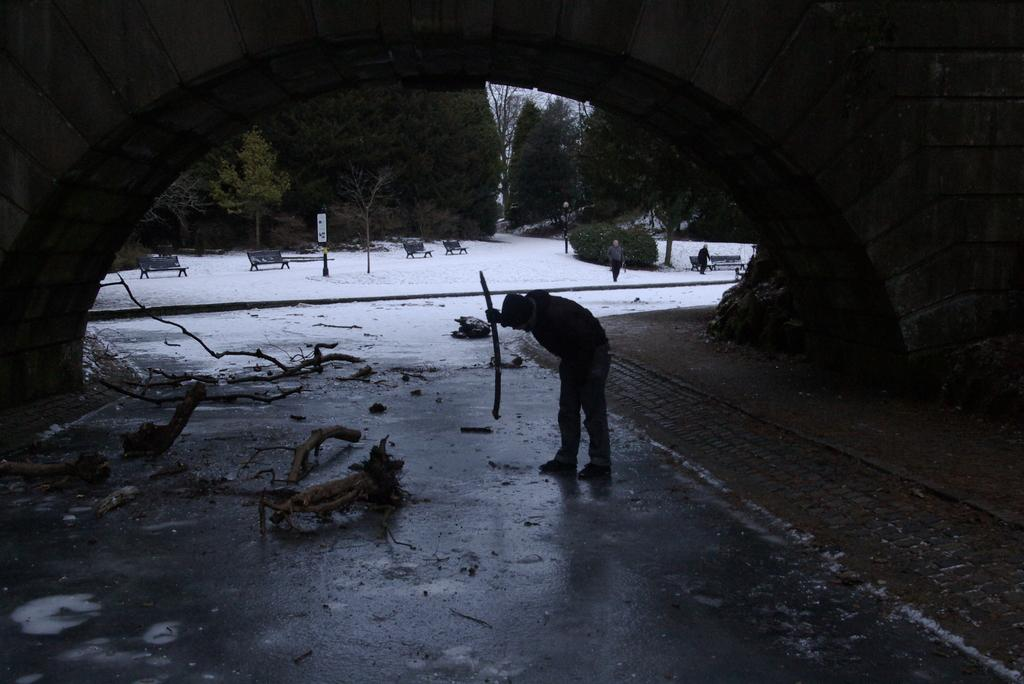What is the person in the image holding? The facts do not specify what the person is holding. What can be seen in the background of the image? In the background, there are benches, signboards, trees, and snow visible. How many different objects can be seen in the background? There are four different objects visible in the background: benches, signboards, trees, and snow. How many deer are visible in the image? There are no deer present in the image. What type of insurance policy is being advertised on the signboards in the image? The facts do not mention any signboards advertising insurance policies. 